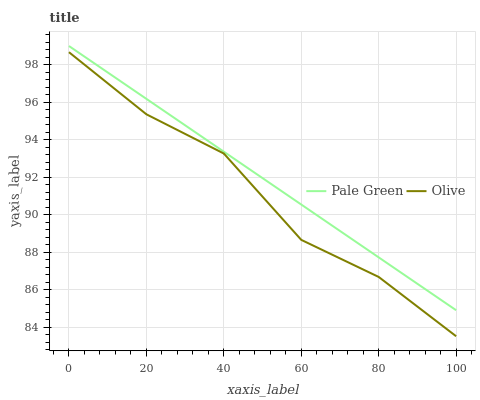Does Olive have the minimum area under the curve?
Answer yes or no. Yes. Does Pale Green have the maximum area under the curve?
Answer yes or no. Yes. Does Pale Green have the minimum area under the curve?
Answer yes or no. No. Is Pale Green the smoothest?
Answer yes or no. Yes. Is Olive the roughest?
Answer yes or no. Yes. Is Pale Green the roughest?
Answer yes or no. No. Does Pale Green have the lowest value?
Answer yes or no. No. Does Pale Green have the highest value?
Answer yes or no. Yes. Is Olive less than Pale Green?
Answer yes or no. Yes. Is Pale Green greater than Olive?
Answer yes or no. Yes. Does Olive intersect Pale Green?
Answer yes or no. No. 